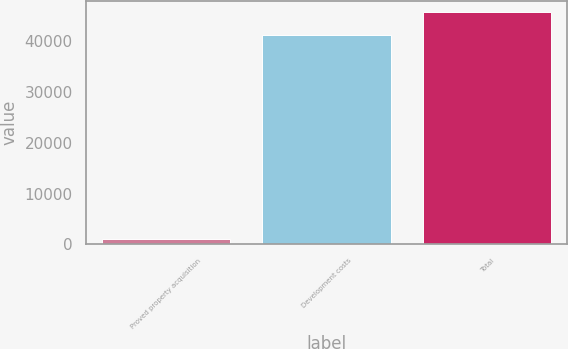Convert chart to OTSL. <chart><loc_0><loc_0><loc_500><loc_500><bar_chart><fcel>Proved property acquisition<fcel>Development costs<fcel>Total<nl><fcel>981<fcel>41110<fcel>45558.6<nl></chart> 